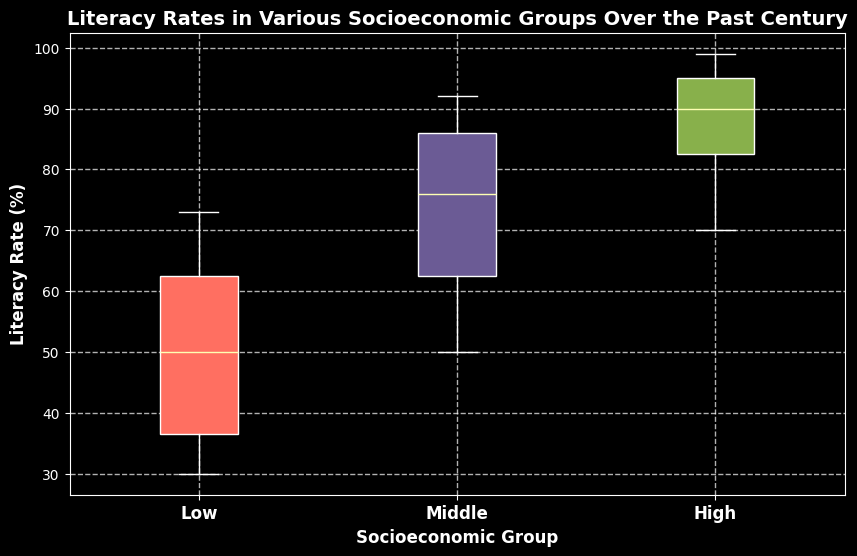What's the median literacy rate for the low socioeconomic group? The median is the value separating the higher half of the data from the lower half. For the low socioeconomic group, the literacy rates are [30, 32, 35, 38, 42, 50, 55, 60, 65, 70, 73]. The middle value (6th value) is the median, which is 50.
Answer: 50 How does the literacy rate in the high socioeconomic group in 1920 compare to 2020? In 1920, the literacy rate for the high socioeconomic group is 70%. In 2020, it is 99%. 99% is significantly higher than 70%, showing considerable improvement over the century.
Answer: Higher in 2020 What is the range of literacy rates for the middle socioeconomic group? The range is the difference between the highest and lowest values. For the middle socioeconomic group, the rates are [50, 55, 60, 65, 70, 76, 80, 84, 88, 90, 92]. The highest rate is 92, and the lowest is 50. The range is 92 - 50.
Answer: 42 Which socioeconomic group shows the most significant improvement in literacy rates from 1920 to 2020? By comparing the differences: High: 99 - 70 = 29, Middle: 92 - 50 = 42, Low: 73 - 30 = 43. The low socioeconomic group has the largest increase.
Answer: Low socioeconomic group What color represents the middle socioeconomic group in the plot? Typically, colors like red, green, and blue are used. From the code, the second assigned color represents the middle group, which is described as #6B5B95, a shade of purple.
Answer: Purple Which socioeconomic group has the most variability in literacy rates over the century? Variability is observed by looking at the spreads and ranges of the box plots. The middle socioeconomic group's range is quite wide (50 to 92), indicating high variability.
Answer: Middle socioeconomic group Is the literacy rate in the middle socioeconomic group in 1980 higher or lower than in 2000? In 1980, the rate is 80%. In 2000, it is 88%. 88% is higher than 80%, so it is higher in 2000.
Answer: Higher What is the interquartile range (IQR) for the low socioeconomic group's literacy rates? The IQR is the difference between the first quartile (Q1) and the third quartile (Q3). For the low group, visually estimate the box plot's lower and upper bounds. Q1 is around 35, and Q3 is around 65. So, IQR = 65 - 35.
Answer: 30 